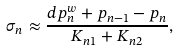Convert formula to latex. <formula><loc_0><loc_0><loc_500><loc_500>\sigma _ { n } \approx \frac { d p ^ { w } _ { n } + p _ { n - 1 } - p _ { n } } { K _ { n 1 } + K _ { n 2 } } ,</formula> 